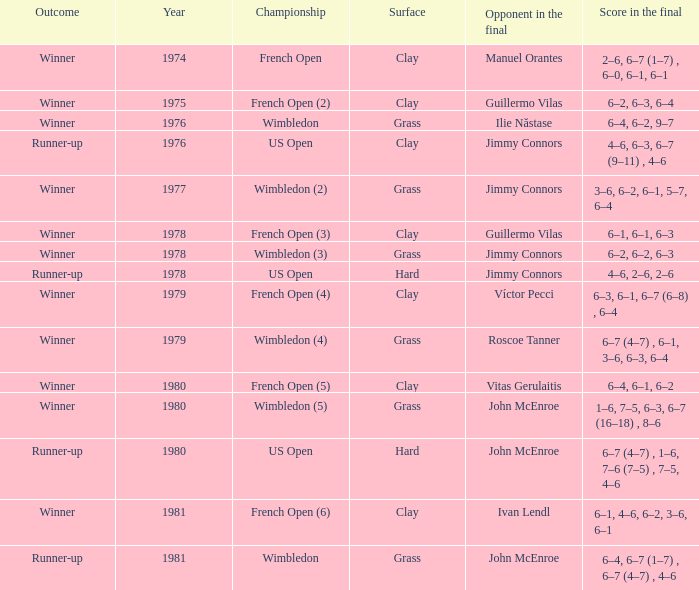What is every surface with a score in the final of 6–4, 6–7 (1–7) , 6–7 (4–7) , 4–6? Grass. 